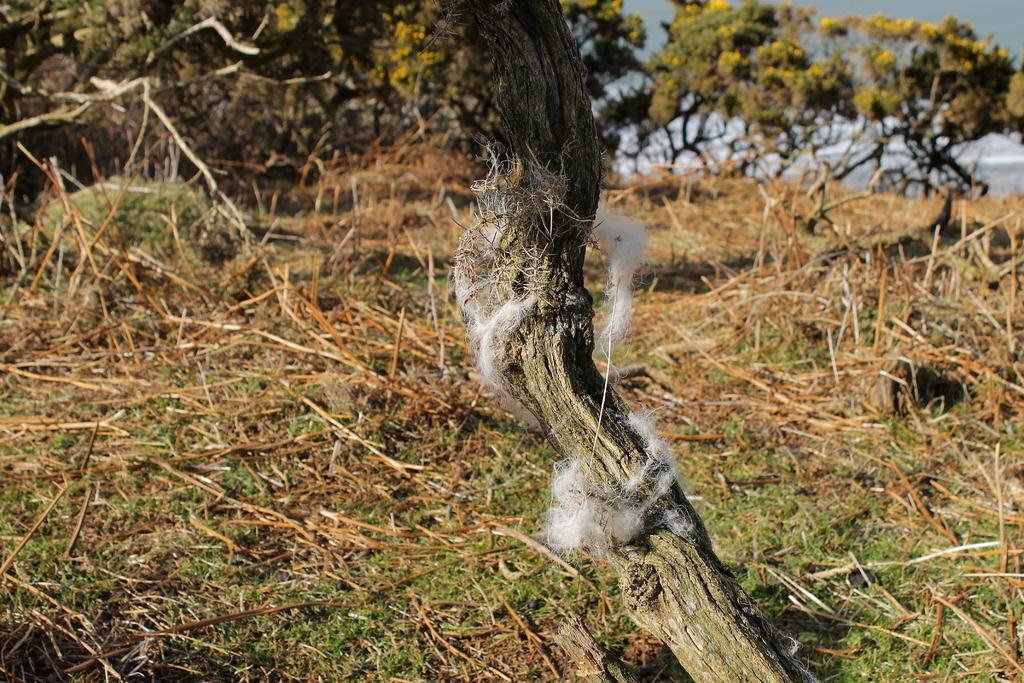Could you give a brief overview of what you see in this image? In this image I can see at the top there are trees, in the middle there is the cotton on this branch of a tree. 